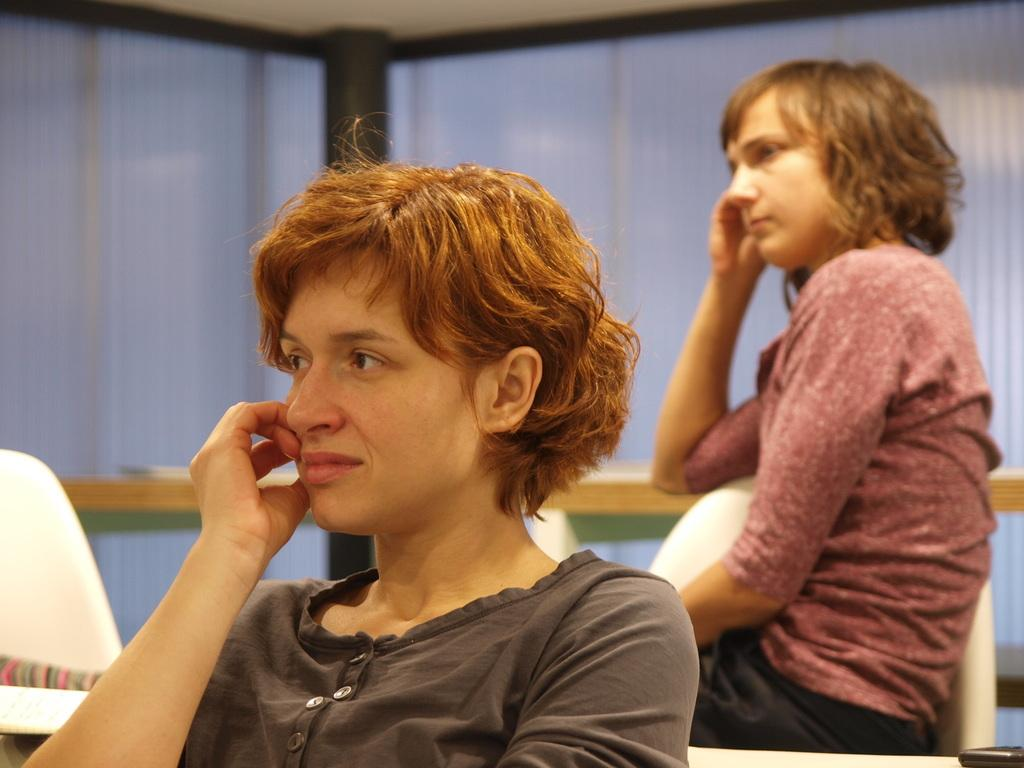How many people are in the image? There are two girls in the image. What are the girls doing in the image? The girls are sitting on chairs. In which direction are the girls looking? The girls are looking to the left side of the image. What is behind the girls in the image? There is a table behind the girls. What can be seen in the background of the image? There is a wall in the background of the image. What type of tongue can be seen sticking out of the wall in the image? There is no tongue visible in the image, and the wall does not have any features that resemble a tongue. 